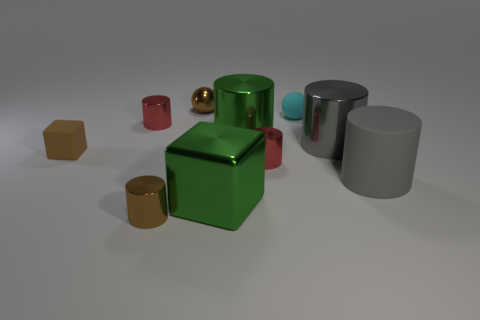Subtract all green metal cylinders. How many cylinders are left? 5 Subtract all gray cylinders. How many cylinders are left? 4 Subtract all blue cylinders. Subtract all cyan balls. How many cylinders are left? 6 Subtract all cylinders. How many objects are left? 4 Subtract all large blue rubber spheres. Subtract all small metallic cylinders. How many objects are left? 7 Add 4 small red cylinders. How many small red cylinders are left? 6 Add 4 cyan spheres. How many cyan spheres exist? 5 Subtract 0 yellow blocks. How many objects are left? 10 